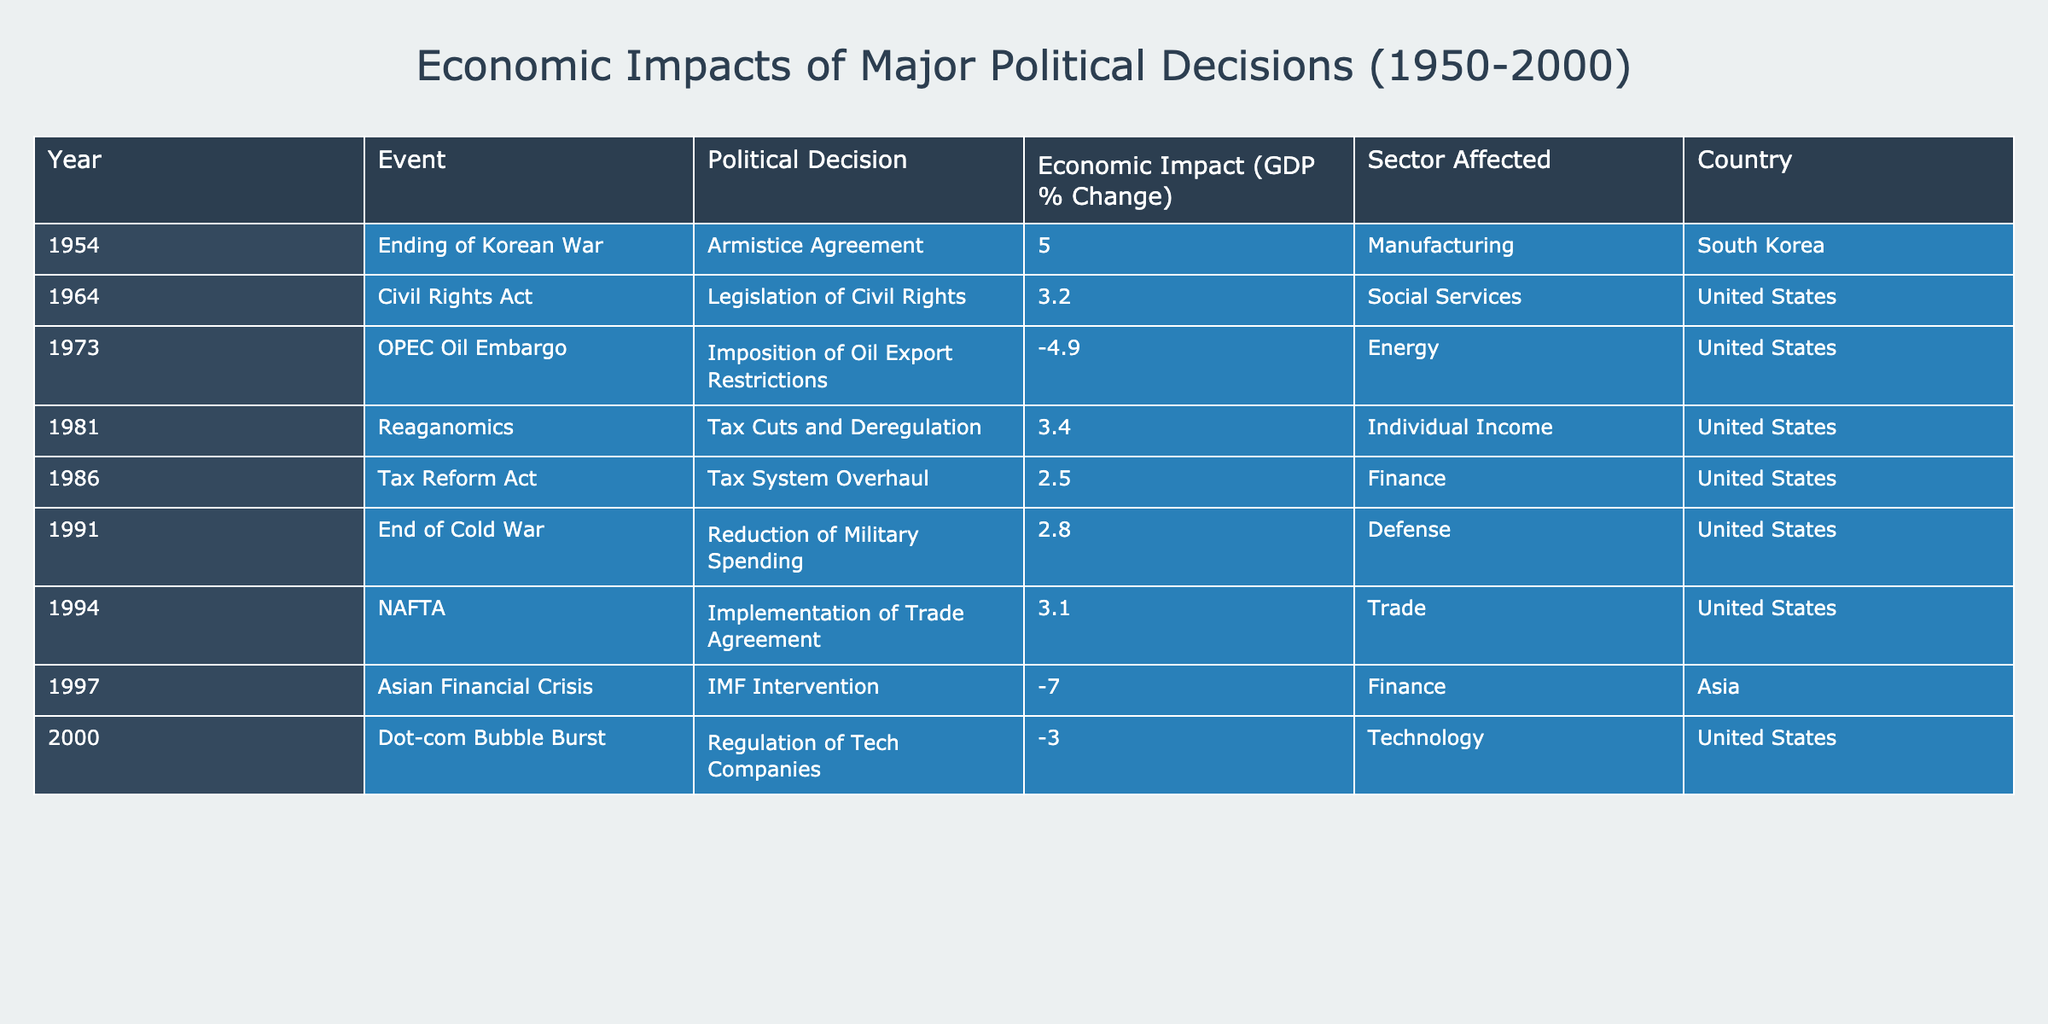What was the economic impact of the Korean War's end in South Korea? The table indicates that the economic impact of the Armistice Agreement ending the Korean War in 1954 resulted in a GDP change of 5.0% in South Korea.
Answer: 5.0% Which country experienced a negative economic impact due to the OPEC Oil Embargo? According to the table, the United States experienced a negative economic impact of -4.9% due to the imposition of oil export restrictions in 1973.
Answer: United States What is the total economic impact of the events listed in the table from 1981 to 1994? To find the total economic impact from 1981 to 1994, we add the GDP changes from Reaganomics (3.4%), Tax Reform Act (2.5%), End of Cold War (2.8%), and NAFTA (3.1%). Summing these values gives 3.4 + 2.5 + 2.8 + 3.1 = 11.8%.
Answer: 11.8% Did the Asian Financial Crisis have a positive or negative economic impact? The table shows that the Asian Financial Crisis resulted in an economic impact of -7.0%, which is a negative impact.
Answer: Negative What was the average economic impact of political decisions in the United States from 1964 to 2000? To calculate the average economic impact of political decisions in the United States, we sum the GDP changes during this period: 3.2 (Civil Rights Act) + (-4.9) (OPEC) + 3.4 (Reaganomics) + 2.5 (Tax Reform Act) + 2.8 (End of Cold War) + 3.1 (NAFTA) + (-3.0) (Dot-com Bubble Burst) = 7.1. There are 7 events, so the average is 7.1 / 7 = 1.014.
Answer: 1.014 Which event had the largest negative impact on economic performance? Reviewing the data, the Asian Financial Crisis had the largest negative impact at -7.0%, making it the worst-performing event in terms of GDP change.
Answer: Asian Financial Crisis Was there any political decision in the table that resulted in a GDP change higher than 5%? The table only lists one event with a GDP change higher than 5%, which is the end of the Korean War in 1954 with a 5.0% change, but there are no entries above that threshold. Therefore, the answer is no.
Answer: No What sectors were affected by the events in the table during the 1980s? From the 1980s entries, the sectors affected were Individual Income (Reaganomics, 1981), Finance (Tax Reform Act, 1986), and Defense (End of Cold War, 1991).
Answer: Individual Income, Finance, Defense What percentage change did the implementation of NAFTA lead to in the trade sector of the United States? The implementation of NAFTA in 1994 resulted in a 3.1% change in the trade sector as shown in the table.
Answer: 3.1% 